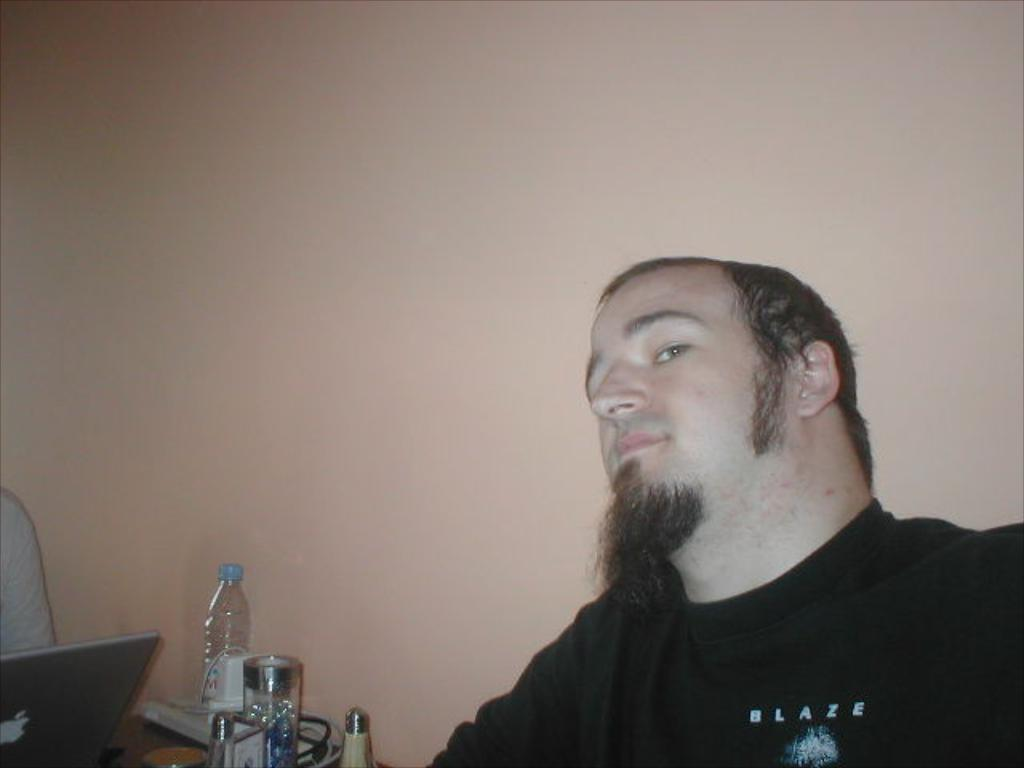What is the appearance of the man in the image? There is a man with a beard in the image. What is the man wearing in the image? The man is wearing a black t-shirt. What objects can be seen on the table in the image? There is a laptop, a bottle, and a mug on the table. What is visible in the background of the image? There is a wall in the background of the image. Can you see any steam coming from the mug in the image? There is no steam visible in the image; the mug's contents are not described. --- Facts: 1. There is a group of people in the image. 2. The people are wearing hats. 3. The people are holding hands. 4. There is a tree in the background of the image. 5. The sky is visible in the image. Absurd Topics: bicycle, parrot, ocean Conversation: How many people are in the image? There is a group of people in the image. What are the people wearing in the image? The people are wearing hats. What are the people doing in the image? The people are holding hands. What can be seen in the background of the image? There is a tree in the background of the image. What is visible above the people in the image? The sky is visible in the image. Reasoning: Let's think step by step in order to produce the conversation. We start by identifying the main subject in the image, which is the group of people. Then, we describe their clothing and actions to provide more detail about their appearance and behavior. Next, we mention the tree in the background to give a sense of the setting. Finally, we acknowledge the presence of the sky to provide context about the weather or time of day. Absurd Question/Answer: Can you see any bicycles or parrots in the image? There are no bicycles or parrots present in the image. The image only features a group of people wearing hats, holding hands, and standing in front of a tree with the sky visible above them. 